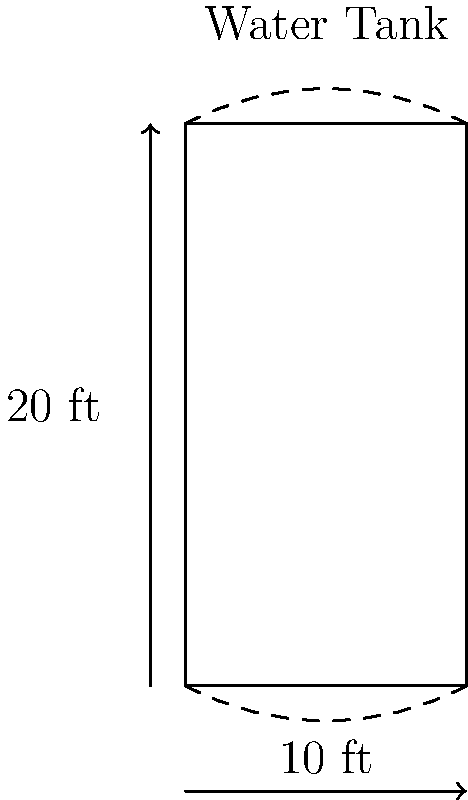You need to estimate the capacity of a cylindrical water storage tank for your campground. The tank has a diameter of 10 feet and a height of 20 feet. Assuming the tank is filled to capacity, approximately how many gallons of water can it hold? (Use π ≈ 3.14 and 1 cubic foot ≈ 7.48 gallons) To calculate the volume of the cylindrical tank and convert it to gallons, we'll follow these steps:

1. Calculate the volume of the cylinder:
   Volume = π * r² * h
   where r is the radius (half the diameter) and h is the height

2. Convert the volume from cubic feet to gallons

Step 1: Calculate the volume
- Radius = 10 ft ÷ 2 = 5 ft
- Height = 20 ft
- Volume = π * 5² * 20
- Volume = 3.14 * 25 * 20 = 1,570 cubic feet

Step 2: Convert to gallons
- 1 cubic foot ≈ 7.48 gallons
- Gallons = 1,570 * 7.48 = 11,743.6 gallons

Therefore, the water tank can hold approximately 11,744 gallons when filled to capacity.
Answer: 11,744 gallons 